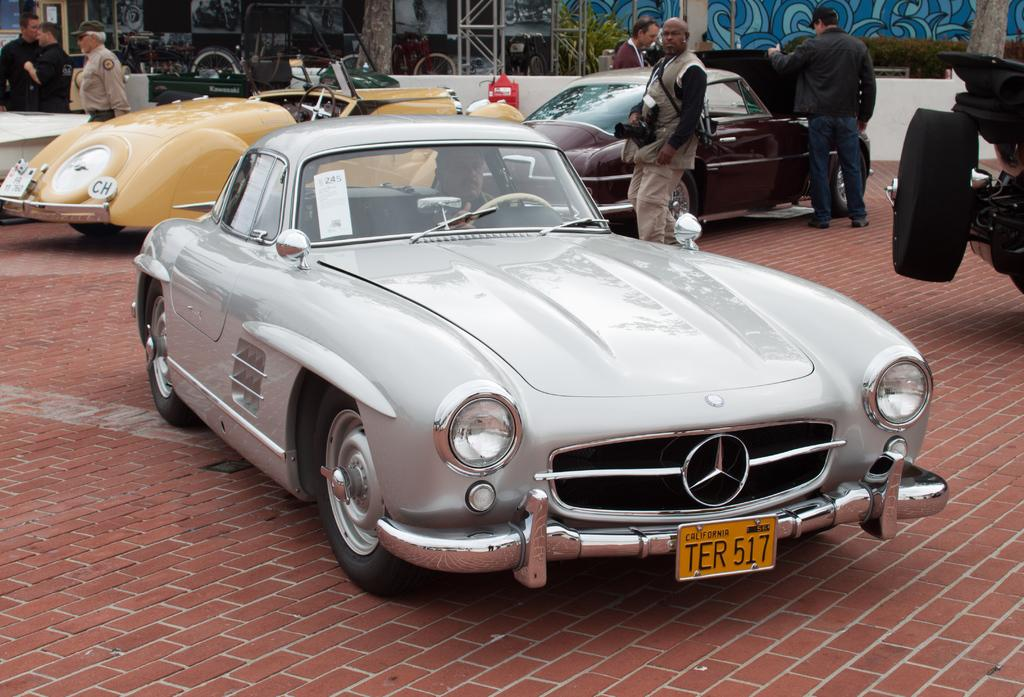What type of vehicles can be seen in the image? There are cars in the image. Are there any people present in the image? Yes, there are people in the image. Can you describe the position of the man in the image? A man is seated in one of the cars. What can be seen in the background of the image? There are trees and buildings in the background of the image. What color is the yarn that the man is knitting in the image? There is no yarn or knitting activity present in the image. What grade is the school building in the background of the image? There is no indication of a school building or any grades in the image. 